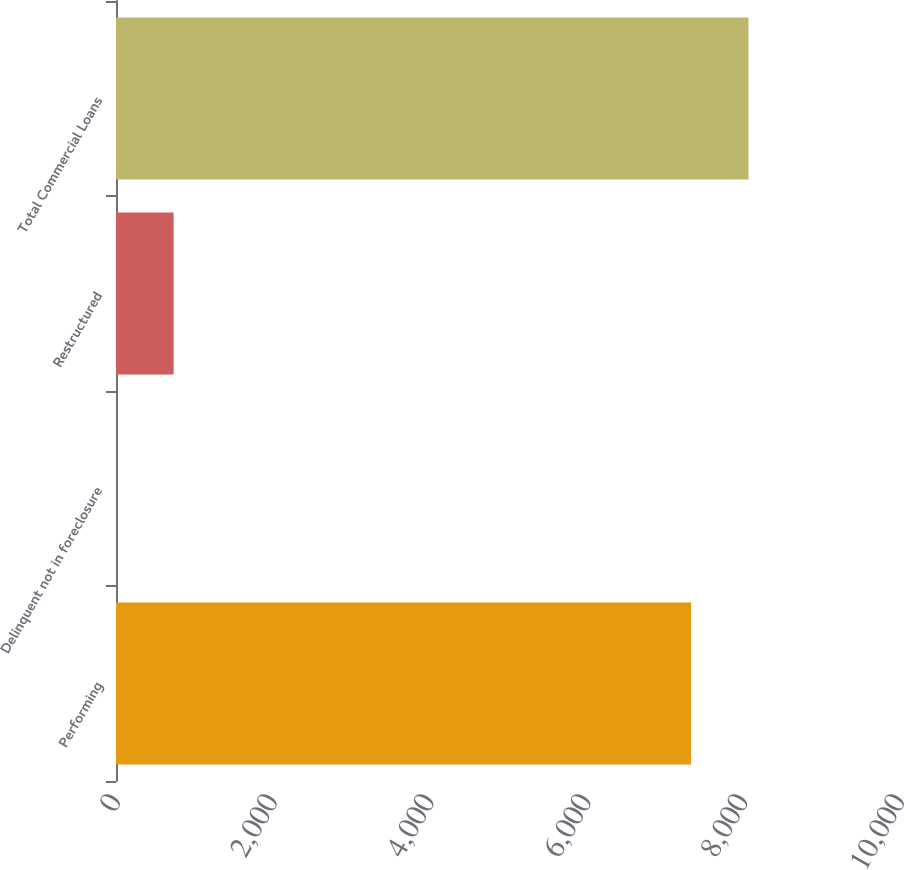Convert chart to OTSL. <chart><loc_0><loc_0><loc_500><loc_500><bar_chart><fcel>Performing<fcel>Delinquent not in foreclosure<fcel>Restructured<fcel>Total Commercial Loans<nl><fcel>7334<fcel>1<fcel>734.7<fcel>8067.7<nl></chart> 